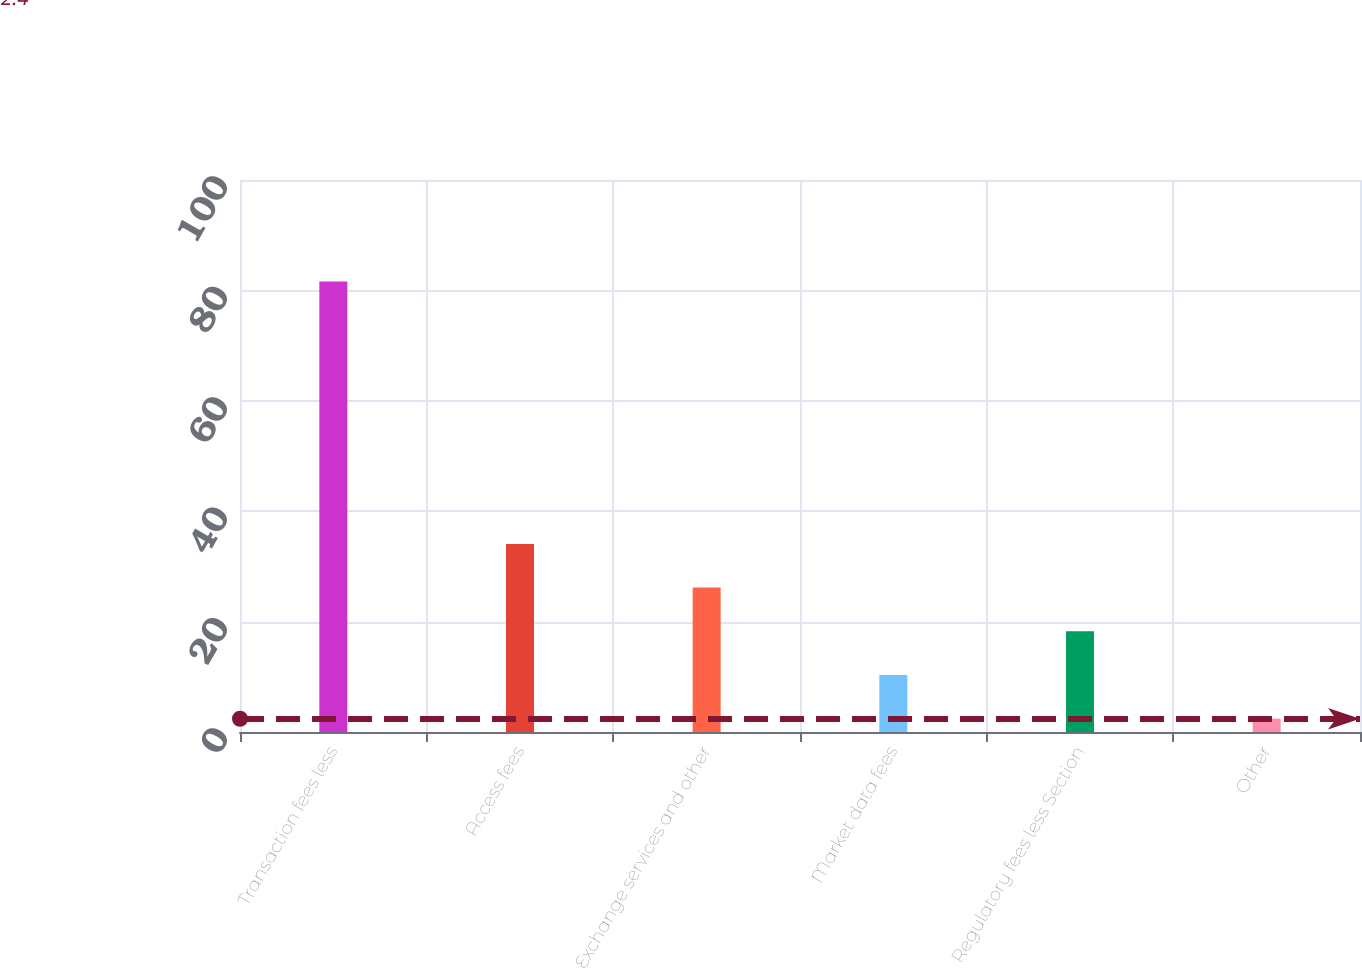Convert chart. <chart><loc_0><loc_0><loc_500><loc_500><bar_chart><fcel>Transaction fees less<fcel>Access fees<fcel>Exchange services and other<fcel>Market data fees<fcel>Regulatory fees less Section<fcel>Other<nl><fcel>81.6<fcel>34.08<fcel>26.16<fcel>10.32<fcel>18.24<fcel>2.4<nl></chart> 